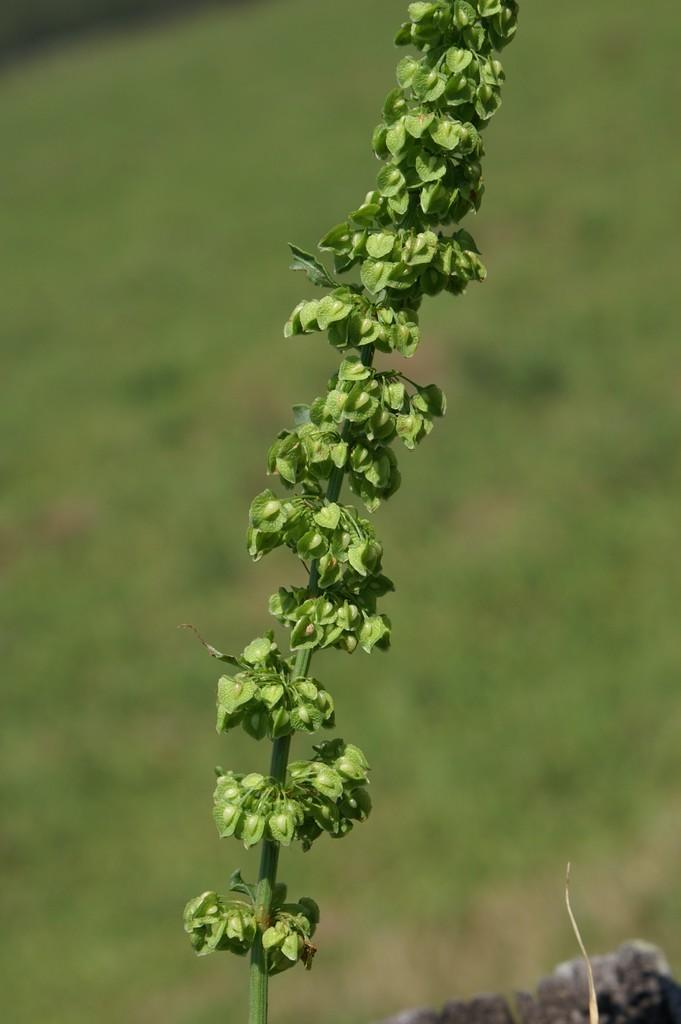What is present in the image? There is a plant in the image. Can you describe the plant? The provided facts do not include a description of the plant. Is there anything else visible in the image besides the plant? The provided facts do not mention any other objects or elements in the image. How many friends are sitting in the basket on the hill in the image? There is no mention of friends, a basket, or a hill in the image. The image only contains a plant. 